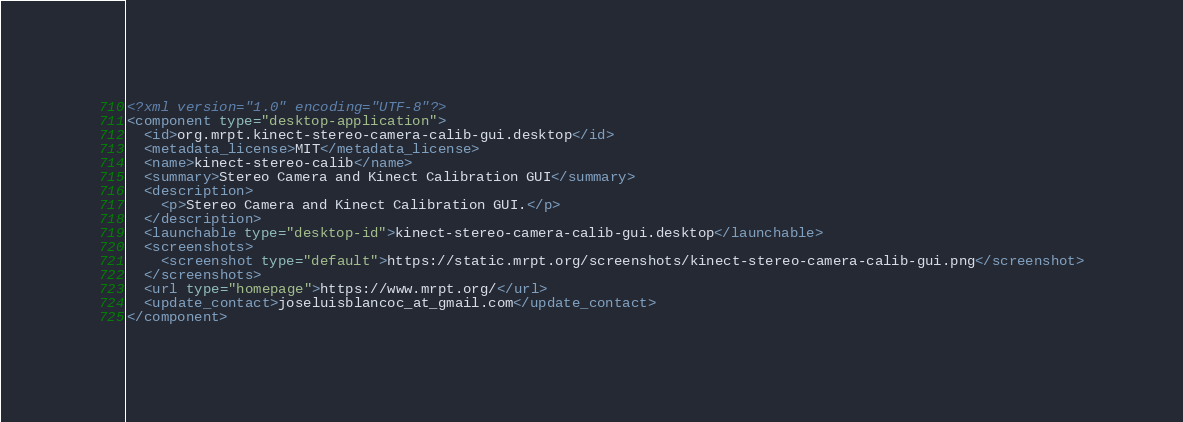<code> <loc_0><loc_0><loc_500><loc_500><_XML_><?xml version="1.0" encoding="UTF-8"?>
<component type="desktop-application">
  <id>org.mrpt.kinect-stereo-camera-calib-gui.desktop</id>
  <metadata_license>MIT</metadata_license>
  <name>kinect-stereo-calib</name>
  <summary>Stereo Camera and Kinect Calibration GUI</summary>
  <description>
    <p>Stereo Camera and Kinect Calibration GUI.</p>
  </description>
  <launchable type="desktop-id">kinect-stereo-camera-calib-gui.desktop</launchable>
  <screenshots>
    <screenshot type="default">https://static.mrpt.org/screenshots/kinect-stereo-camera-calib-gui.png</screenshot>
  </screenshots>
  <url type="homepage">https://www.mrpt.org/</url>
  <update_contact>joseluisblancoc_at_gmail.com</update_contact>
</component>
</code> 